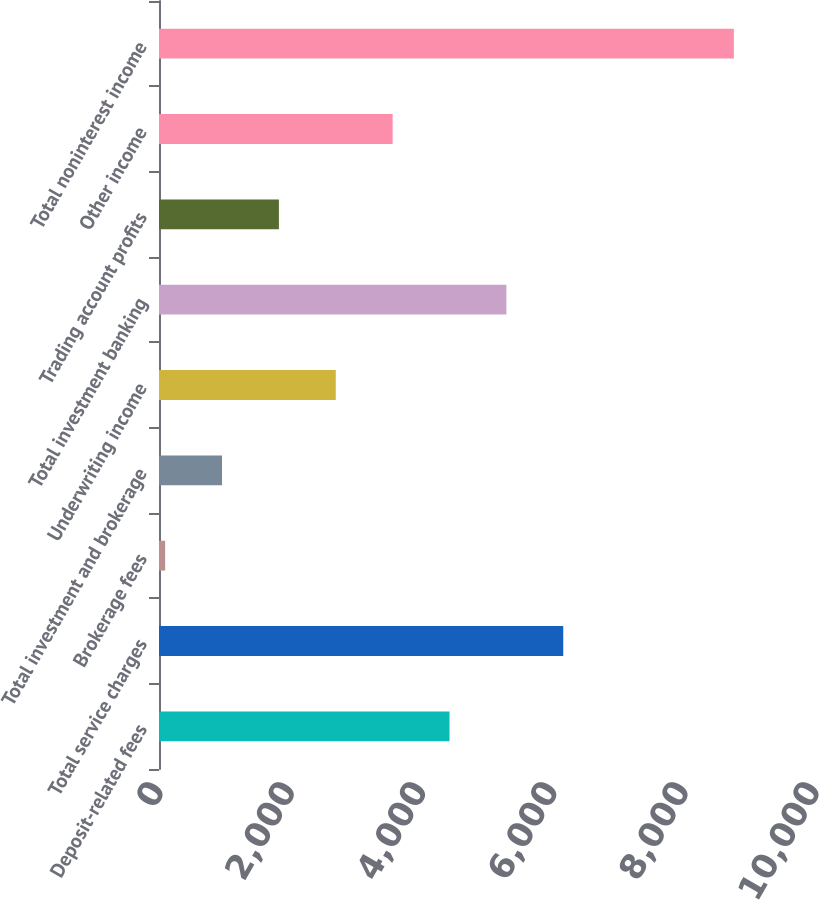Convert chart. <chart><loc_0><loc_0><loc_500><loc_500><bar_chart><fcel>Deposit-related fees<fcel>Total service charges<fcel>Brokerage fees<fcel>Total investment and brokerage<fcel>Underwriting income<fcel>Total investment banking<fcel>Trading account profits<fcel>Other income<fcel>Total noninterest income<nl><fcel>4428.5<fcel>6162.3<fcel>94<fcel>960.9<fcel>2694.7<fcel>5295.4<fcel>1827.8<fcel>3561.6<fcel>8763<nl></chart> 